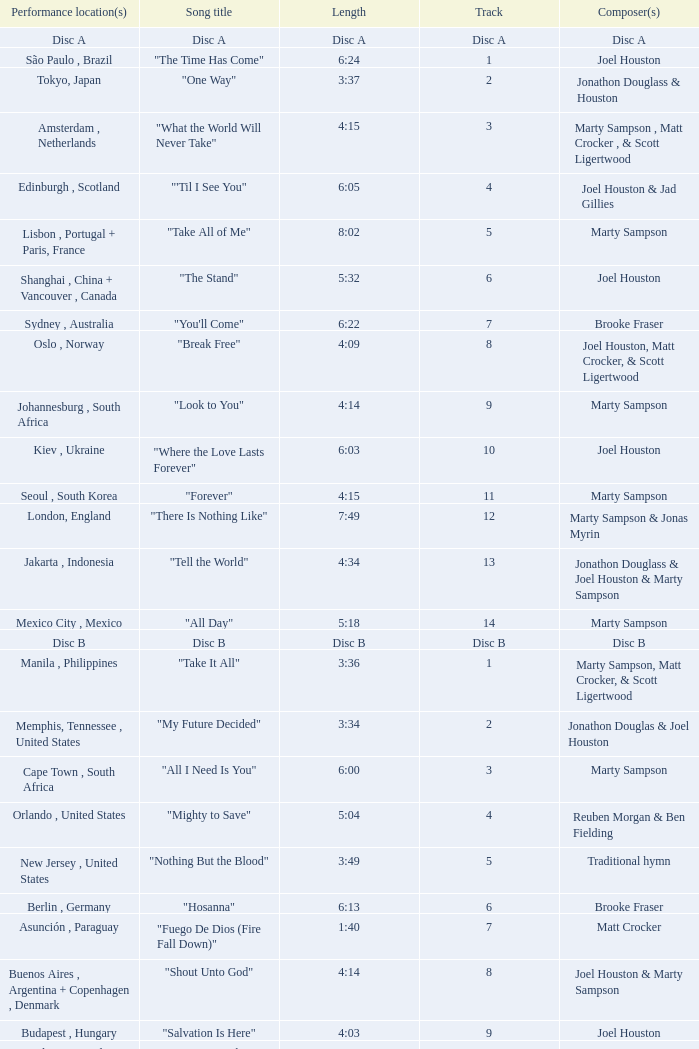Who is the composer of the song with a length of 6:24? Joel Houston. 